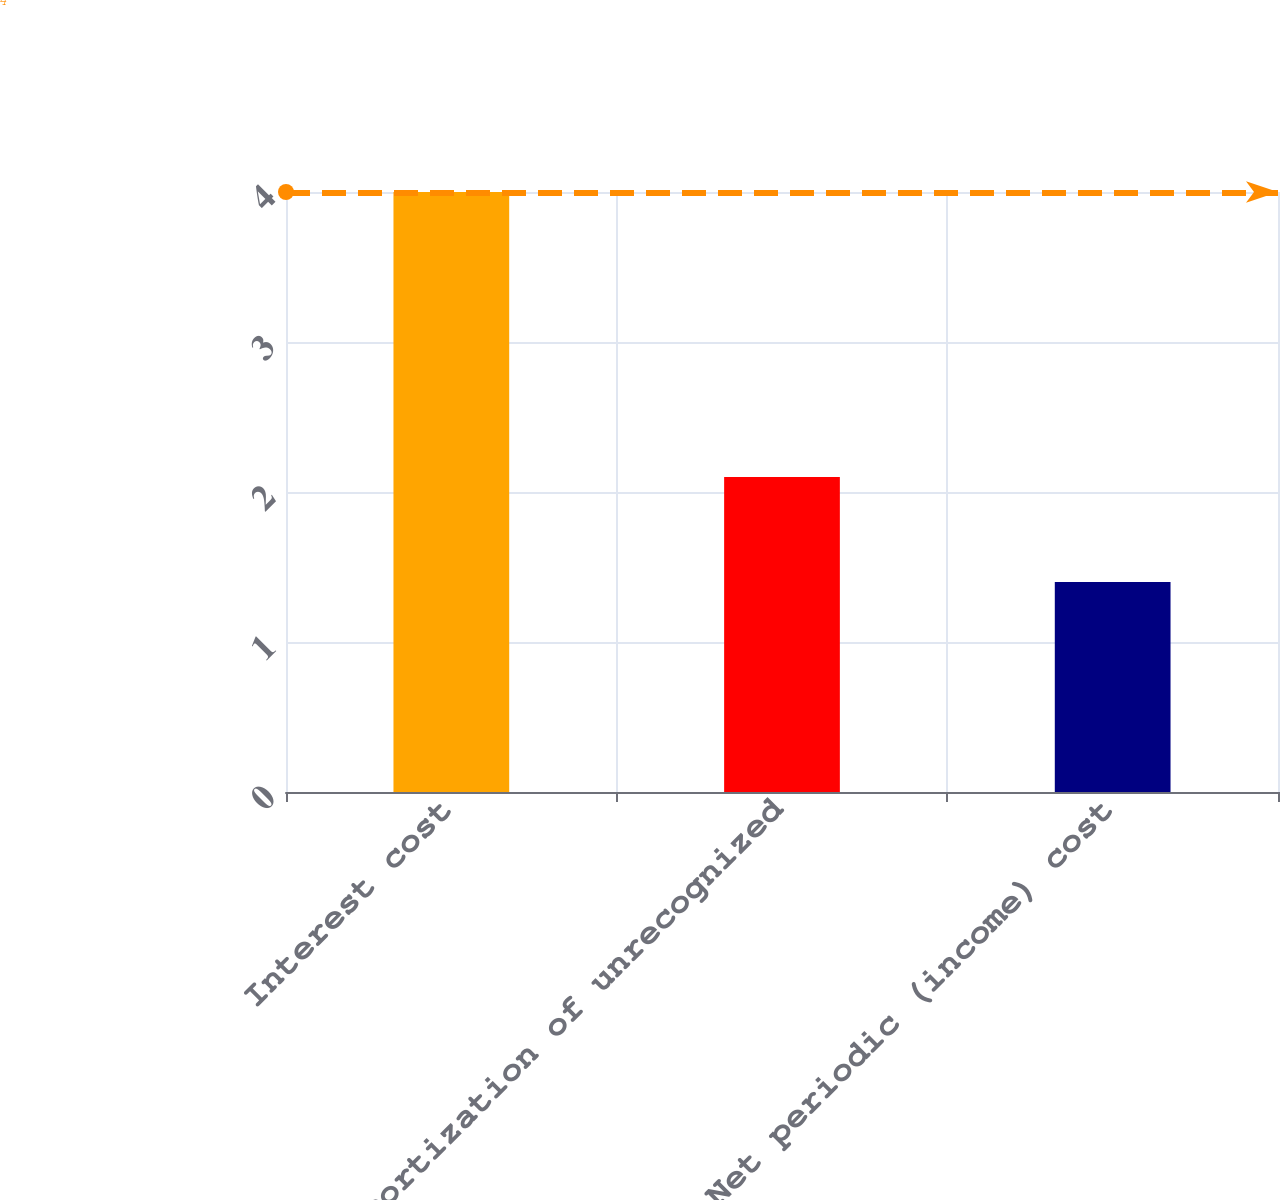<chart> <loc_0><loc_0><loc_500><loc_500><bar_chart><fcel>Interest cost<fcel>Amortization of unrecognized<fcel>Net periodic (income) cost<nl><fcel>4<fcel>2.1<fcel>1.4<nl></chart> 